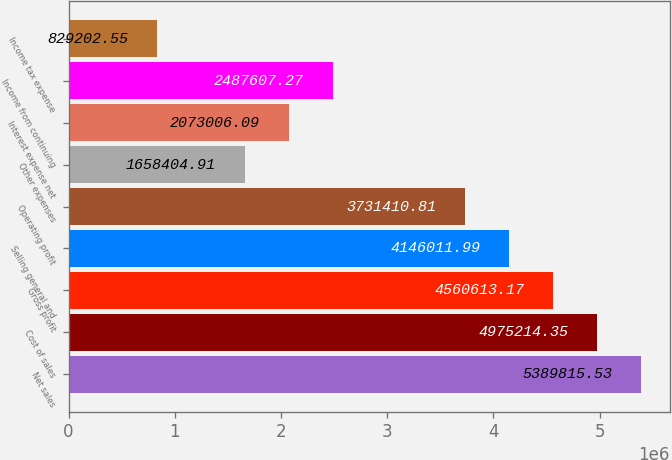<chart> <loc_0><loc_0><loc_500><loc_500><bar_chart><fcel>Net sales<fcel>Cost of sales<fcel>Gross profit<fcel>Selling general and<fcel>Operating profit<fcel>Other expenses<fcel>Interest expense net<fcel>Income from continuing<fcel>Income tax expense<nl><fcel>5.38982e+06<fcel>4.97521e+06<fcel>4.56061e+06<fcel>4.14601e+06<fcel>3.73141e+06<fcel>1.6584e+06<fcel>2.07301e+06<fcel>2.48761e+06<fcel>829203<nl></chart> 